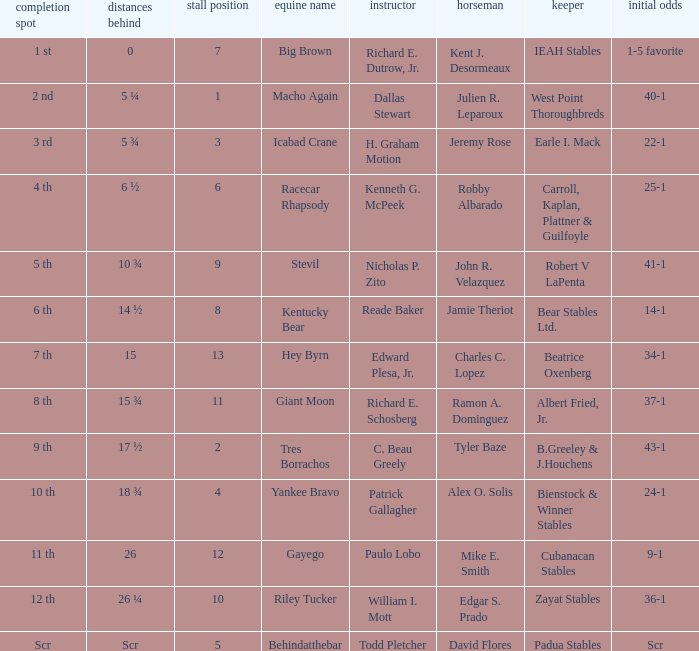Who is the owner of Icabad Crane? Earle I. Mack. 